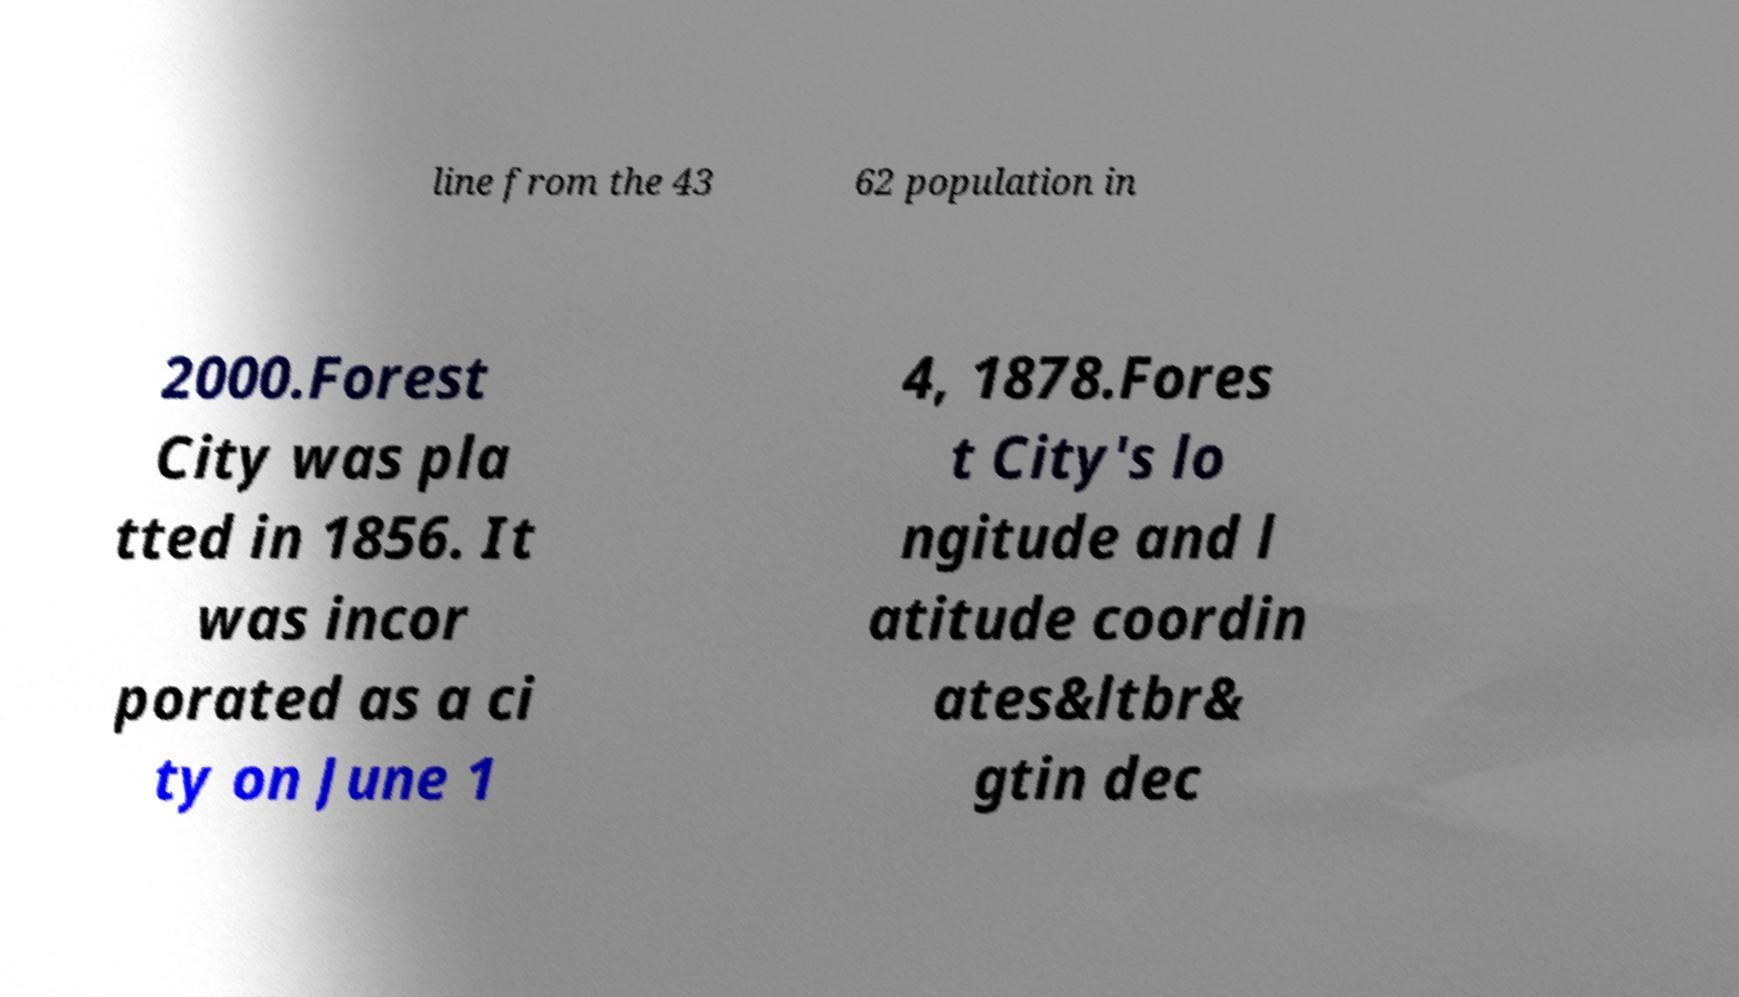There's text embedded in this image that I need extracted. Can you transcribe it verbatim? line from the 43 62 population in 2000.Forest City was pla tted in 1856. It was incor porated as a ci ty on June 1 4, 1878.Fores t City's lo ngitude and l atitude coordin ates&ltbr& gtin dec 